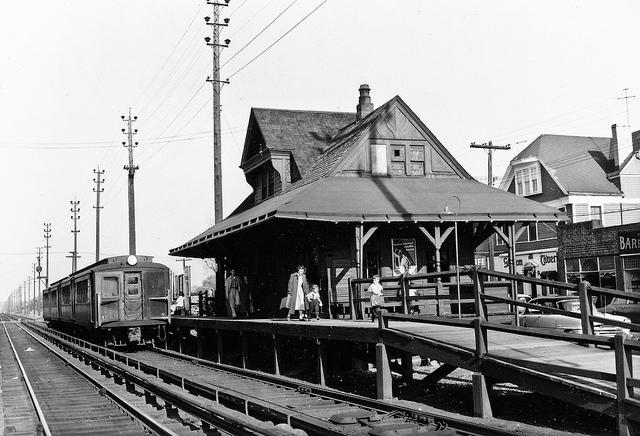How many people in the photo?
Quick response, please. 5. What is the building?
Be succinct. Train station. Is this photo from this century?
Give a very brief answer. No. 